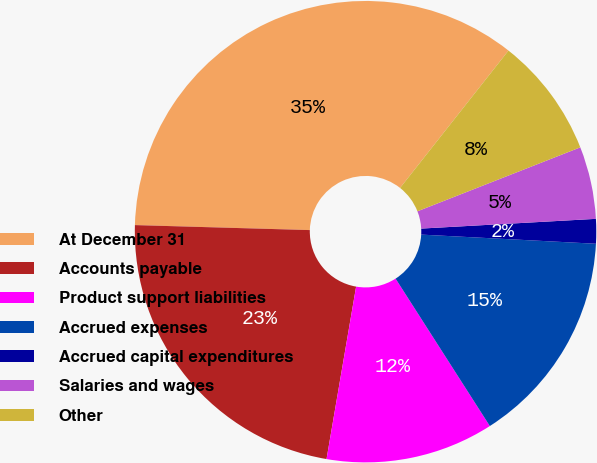<chart> <loc_0><loc_0><loc_500><loc_500><pie_chart><fcel>At December 31<fcel>Accounts payable<fcel>Product support liabilities<fcel>Accrued expenses<fcel>Accrued capital expenditures<fcel>Salaries and wages<fcel>Other<nl><fcel>35.18%<fcel>22.75%<fcel>11.76%<fcel>15.11%<fcel>1.72%<fcel>5.07%<fcel>8.41%<nl></chart> 